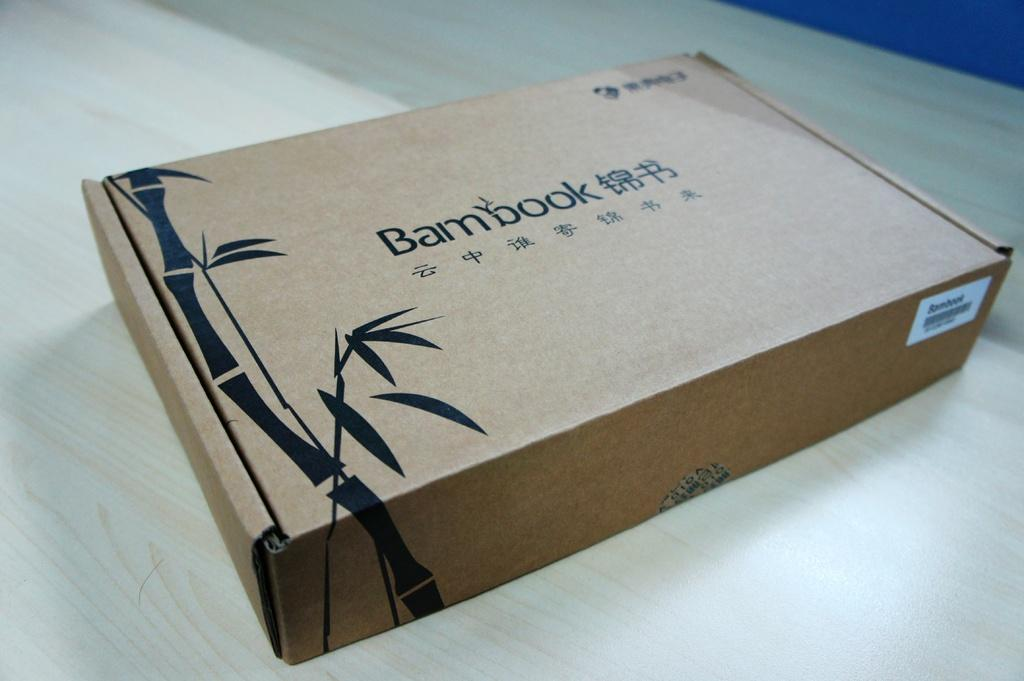Provide a one-sentence caption for the provided image. A Bambook cardboard box is resting on a wooden table. 